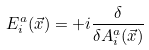<formula> <loc_0><loc_0><loc_500><loc_500>E ^ { a } _ { i } ( \vec { x } ) = + i \frac { \delta } { \delta A ^ { a } _ { i } ( \vec { x } ) }</formula> 